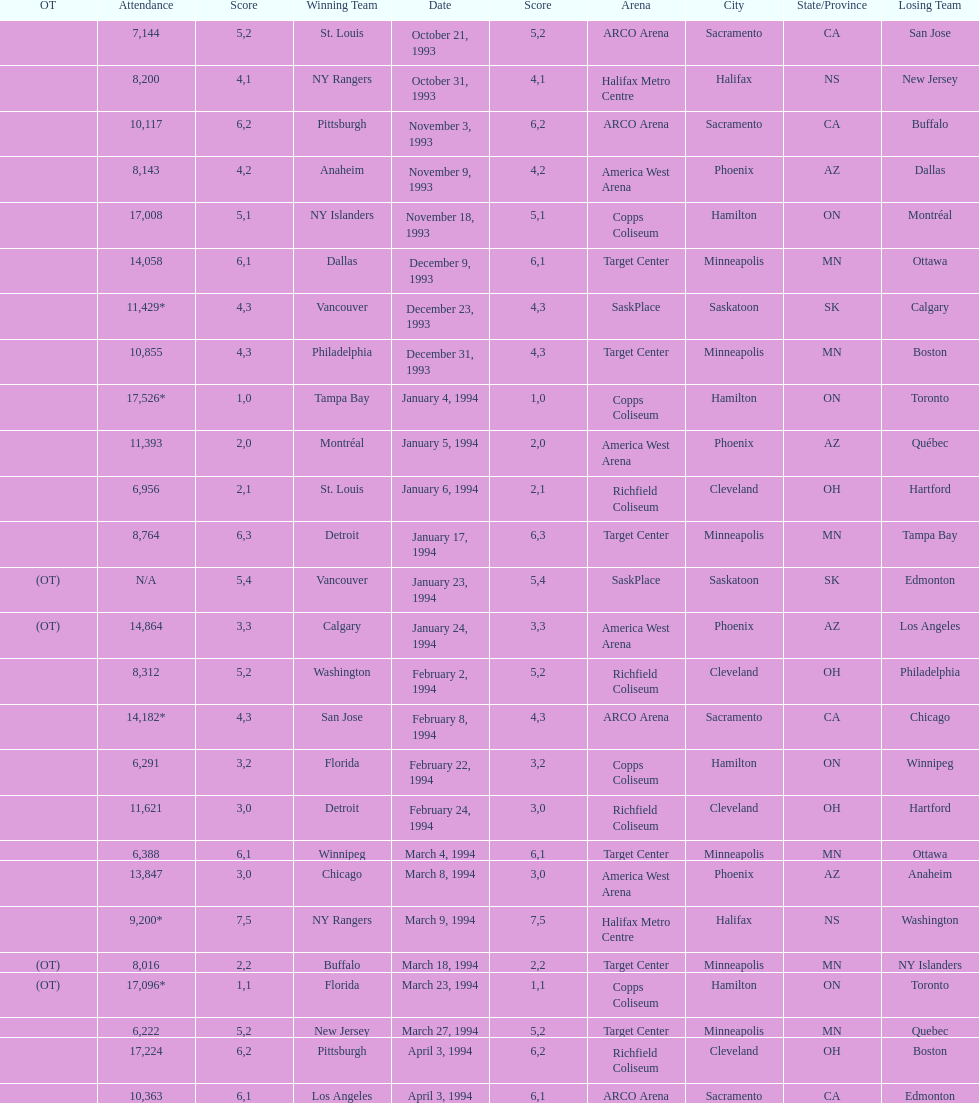How many games have been held in minneapolis? 6. 